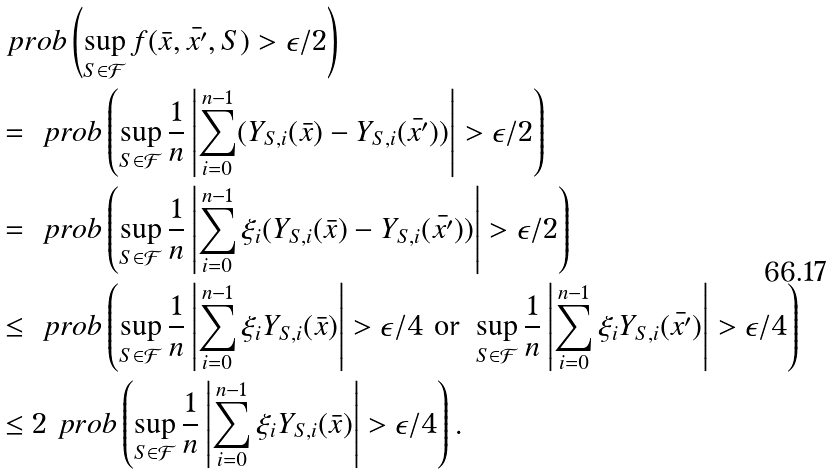Convert formula to latex. <formula><loc_0><loc_0><loc_500><loc_500>& \ p r o b \left ( \sup _ { S \in \mathcal { F } } f ( \bar { x } , \bar { x ^ { \prime } } , S ) > \epsilon / 2 \right ) \\ & = \ p r o b \left ( \sup _ { S \in \mathcal { F } } \frac { 1 } { n } \left | \sum _ { i = 0 } ^ { n - 1 } ( Y _ { S , i } ( \bar { x } ) - Y _ { S , i } ( \bar { x ^ { \prime } } ) ) \right | > \epsilon / 2 \right ) \\ & = \ p r o b \left ( \sup _ { S \in \mathcal { F } } \frac { 1 } { n } \left | \sum _ { i = 0 } ^ { n - 1 } \xi _ { i } ( Y _ { S , i } ( \bar { x } ) - Y _ { S , i } ( \bar { x ^ { \prime } } ) ) \right | > \epsilon / 2 \right ) \\ & \leq \ p r o b \left ( \sup _ { S \in \mathcal { F } } \frac { 1 } { n } \left | \sum _ { i = 0 } ^ { n - 1 } \xi _ { i } Y _ { S , i } ( \bar { x } ) \right | > \epsilon / 4 \text { or } \sup _ { S \in \mathcal { F } } \frac { 1 } { n } \left | \sum _ { i = 0 } ^ { n - 1 } \xi _ { i } Y _ { S , i } ( \bar { x ^ { \prime } } ) \right | > \epsilon / 4 \right ) \\ & \leq 2 \ p r o b \left ( \sup _ { S \in \mathcal { F } } \frac { 1 } { n } \left | \sum _ { i = 0 } ^ { n - 1 } \xi _ { i } Y _ { S , i } ( \bar { x } ) \right | > \epsilon / 4 \right ) .</formula> 